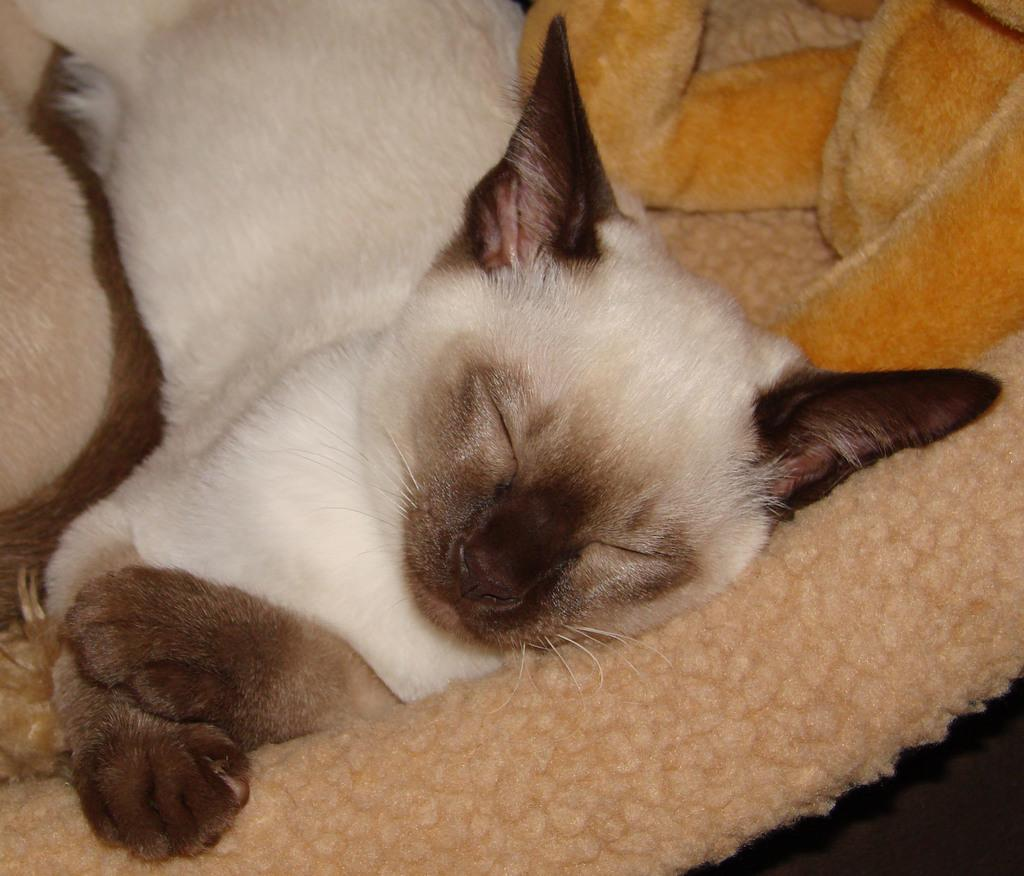What type of animal is in the image? There is a cat in the image. What is the cat doing in the image? The cat is sleeping. Where is the cat located in the image? The cat is on a cat bed. What else can be seen on the cat bed? There are toys visible on the bed. What type of agreement is being signed by the cat in the image? There is no agreement being signed in the image; the cat is sleeping on a cat bed with toys. 